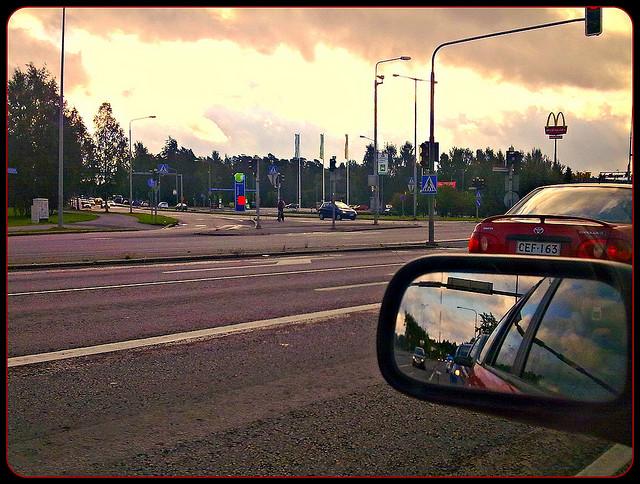What color are the lines on the road?
Write a very short answer. White. What object is in front of the sign?
Quick response, please. Car. What fast food restaurant is in the distance?
Short answer required. Mcdonald's. Are the streets busy?
Give a very brief answer. No. Why is traffic at a standstill?
Give a very brief answer. Red light. What is the vehicle?
Short answer required. Car. 